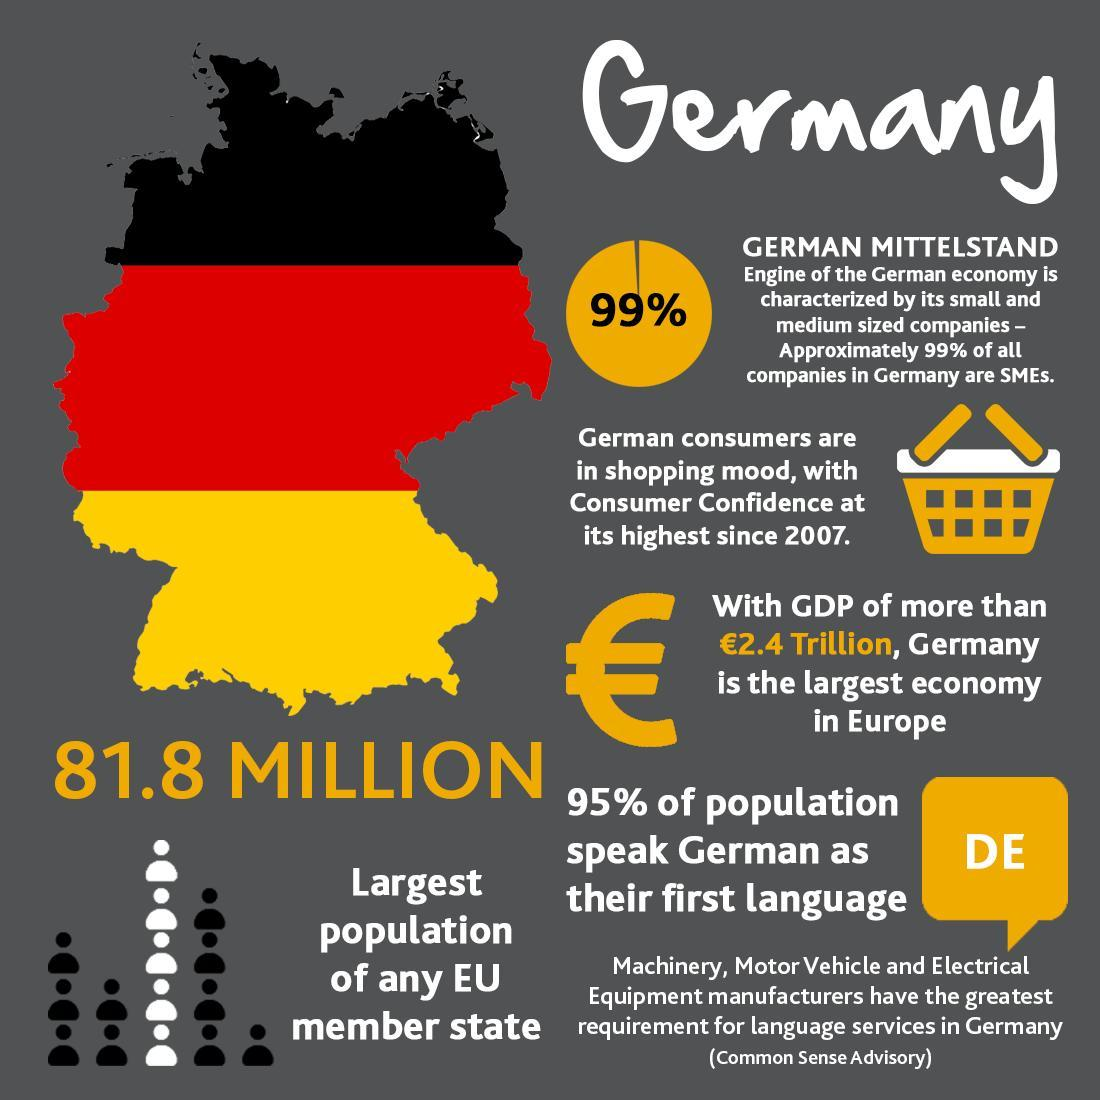How many colors are in the flags of Germany?
Answer the question with a short phrase. 3 